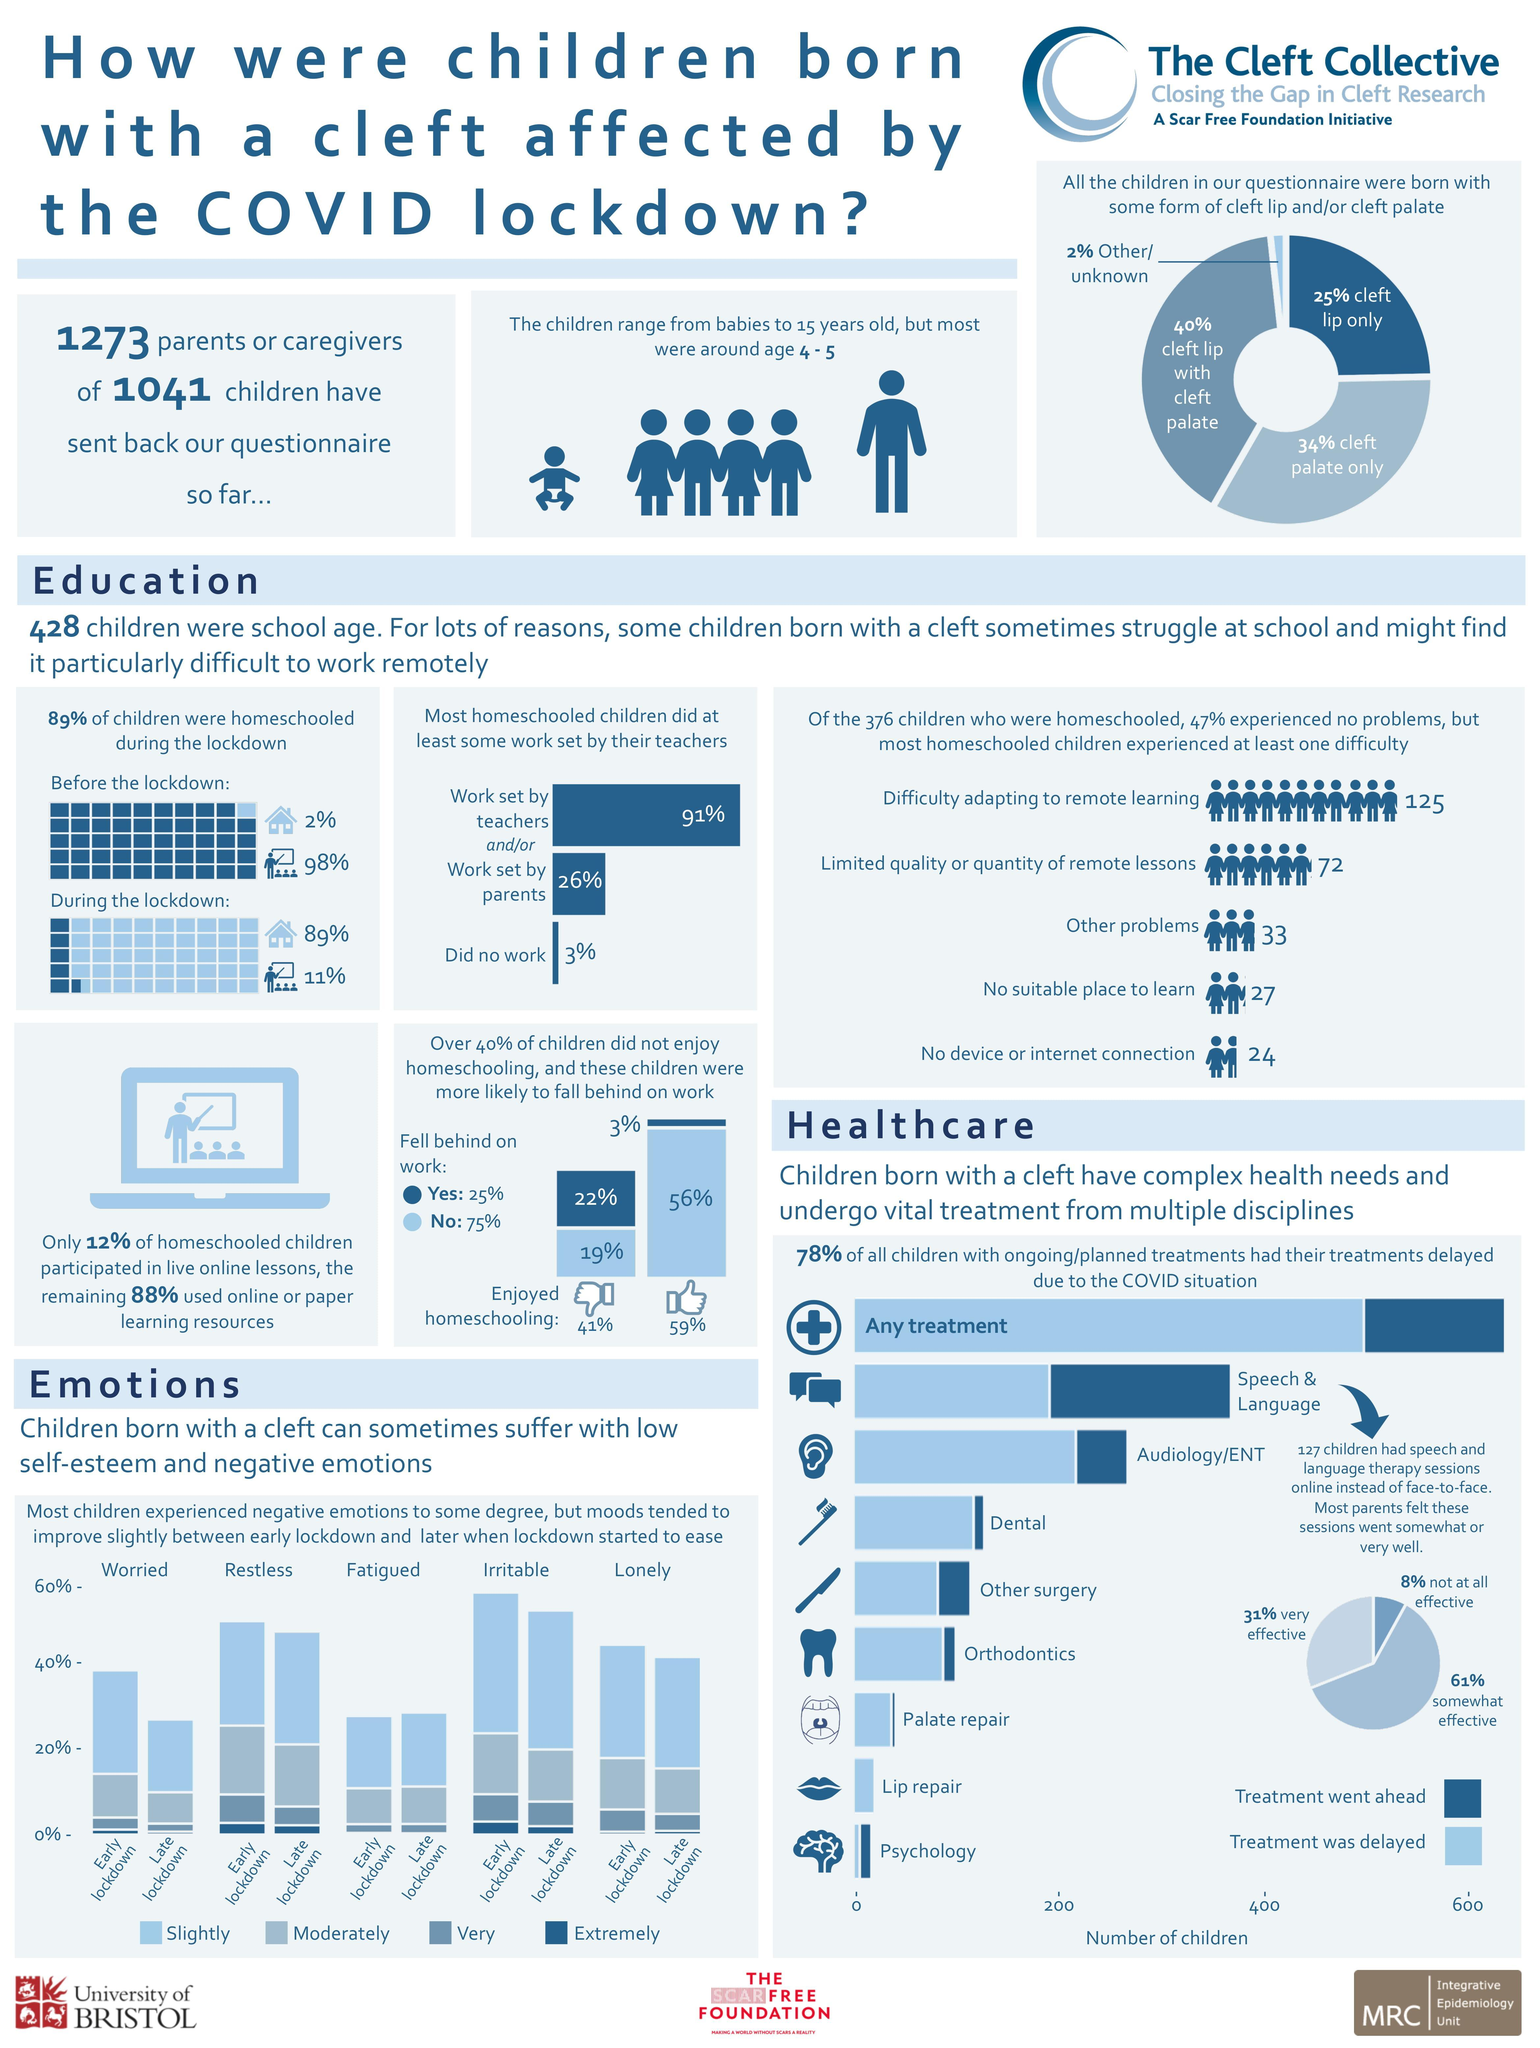How many of the children attended regular school during lockdown?
Answer the question with a short phrase. 11% How many of the children were homeschooled before lockdown? 2% What percent of homeschooled children did not attend live online lessons? 88% How many parents felt that online speech and language therapy sessions were not effective? 8% How many of the children who did not enjoy being homeschooled fell behind on their works? 22% Which planned treatment did not go ahead for any children due to the COVID situation? Lip repair How many of the children who enjoyed being homeschooled fell behind on work? 3% Most of the children were of which ages? 4 - 5 What percent of all the children enjoyed being homeschooled? 59% What percent of the children didn't enjoy homeschooling but did not fall behind on work? 19% 